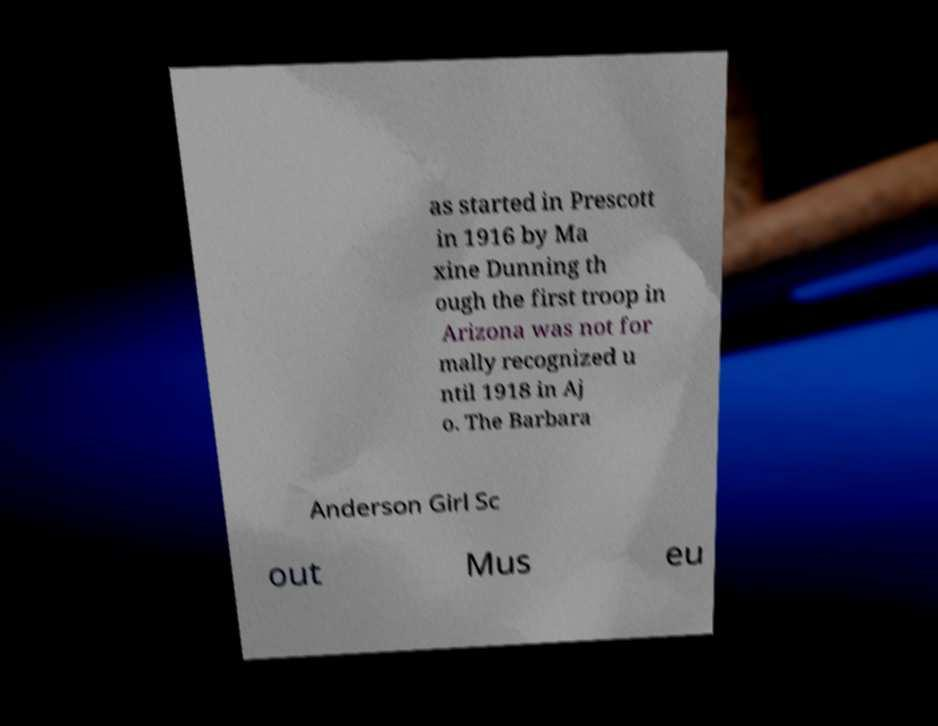Can you read and provide the text displayed in the image?This photo seems to have some interesting text. Can you extract and type it out for me? as started in Prescott in 1916 by Ma xine Dunning th ough the first troop in Arizona was not for mally recognized u ntil 1918 in Aj o. The Barbara Anderson Girl Sc out Mus eu 